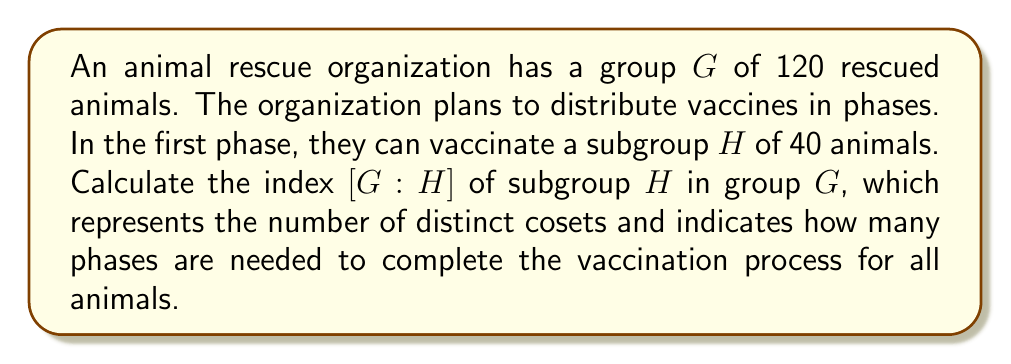Help me with this question. To solve this problem, we need to understand the concept of index in group theory and how it applies to our vaccination scenario:

1) The index of a subgroup $H$ in a group $G$, denoted as $[G:H]$, is defined as the number of distinct left (or right) cosets of $H$ in $G$.

2) For finite groups, the index can be calculated using the formula:

   $$[G:H] = \frac{|G|}{|H|}$$

   where $|G|$ is the order (number of elements) of group $G$, and $|H|$ is the order of subgroup $H$.

3) In our case:
   - $|G| = 120$ (total number of rescued animals)
   - $|H| = 40$ (number of animals that can be vaccinated in one phase)

4) Applying the formula:

   $$[G:H] = \frac{|G|}{|H|} = \frac{120}{40} = 3$$

5) Interpretation: The index 3 means there are 3 distinct cosets of $H$ in $G$. In the context of our vaccination program, this indicates that we need 3 phases to vaccinate all animals.

Each phase corresponds to a coset, vaccinating a different set of 40 animals, until all 120 animals are covered in 3 phases.
Answer: $[G:H] = 3$ 